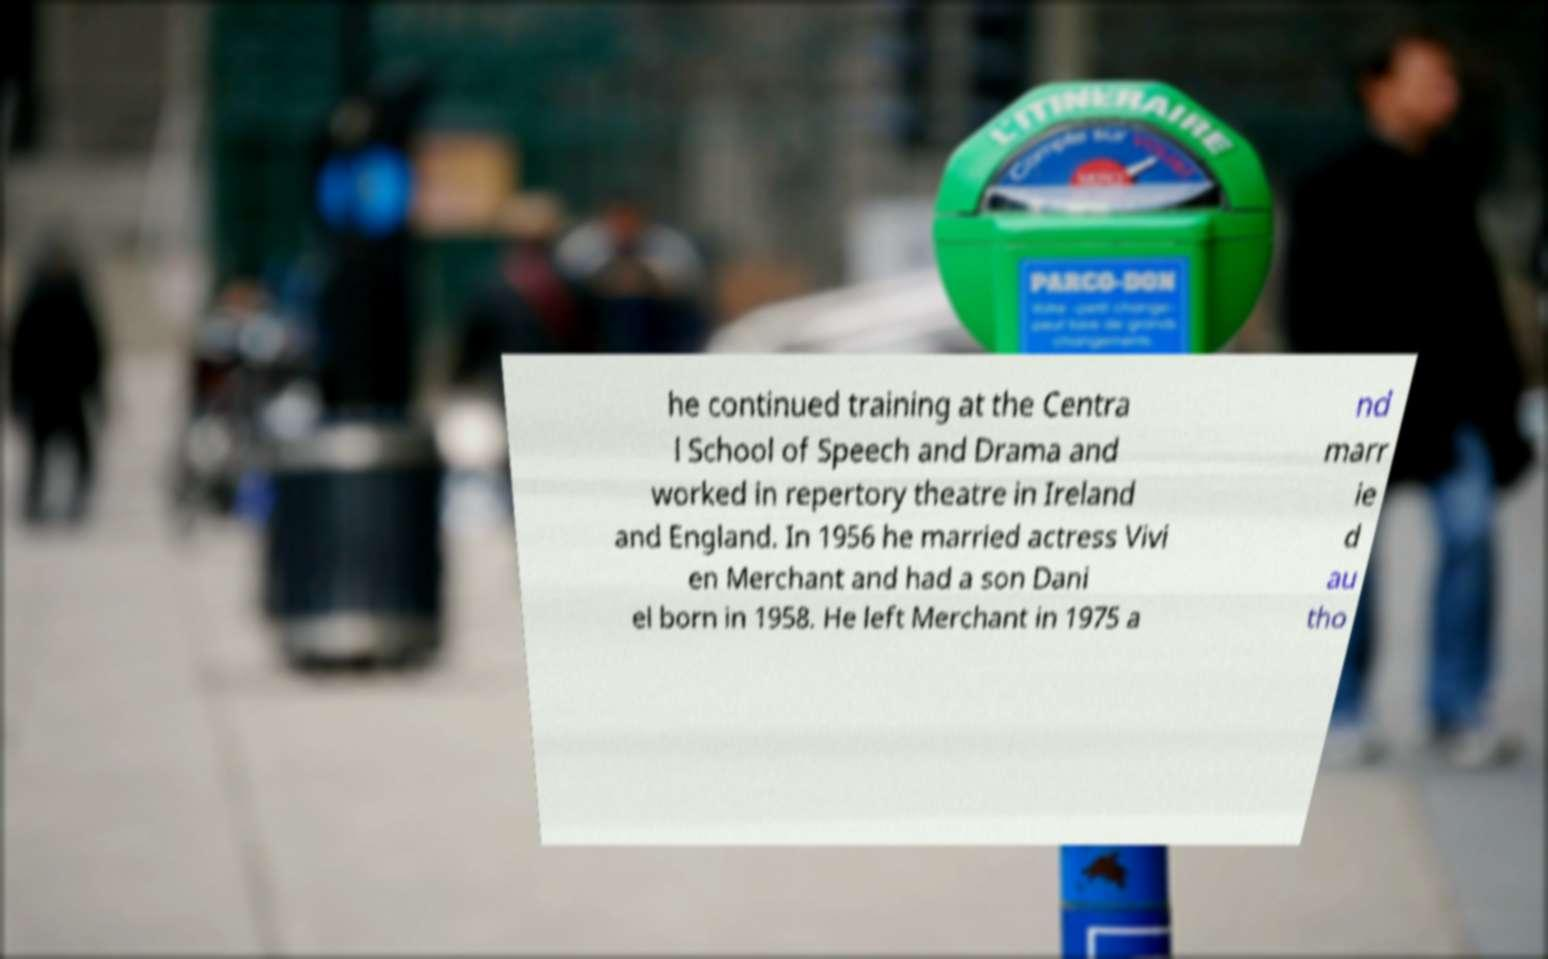Can you accurately transcribe the text from the provided image for me? he continued training at the Centra l School of Speech and Drama and worked in repertory theatre in Ireland and England. In 1956 he married actress Vivi en Merchant and had a son Dani el born in 1958. He left Merchant in 1975 a nd marr ie d au tho 